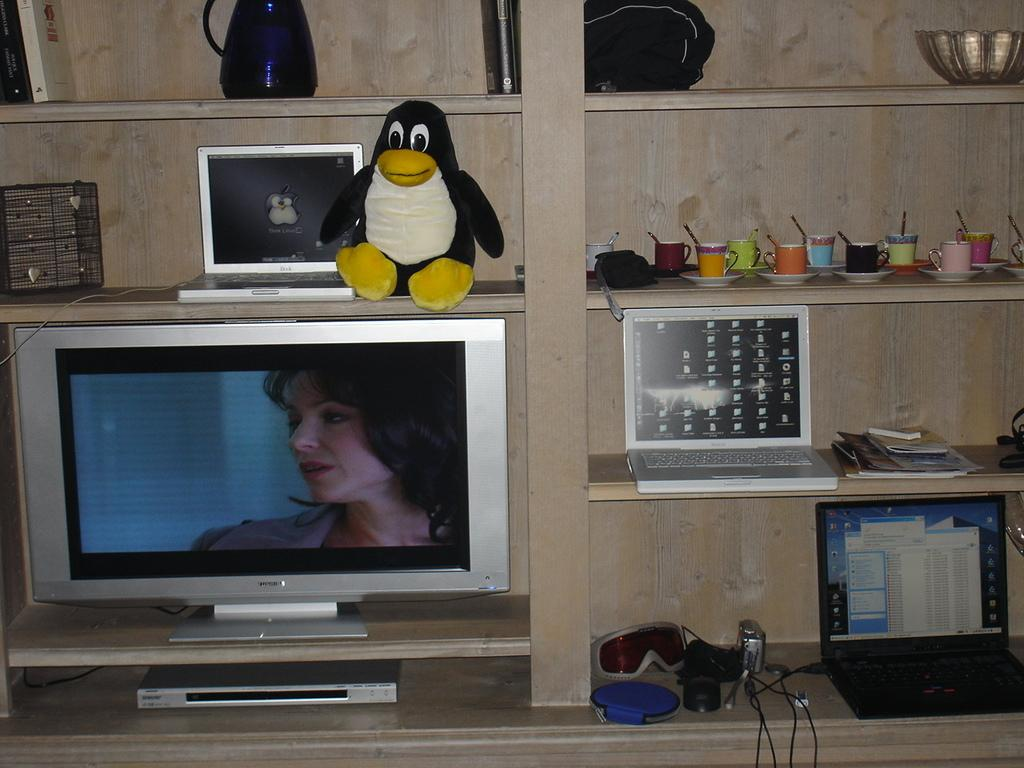What can be seen in the shelves in the image? There are objects placed in shelves in the image. What type of electronic device is present in the image? There is a TV in the image. What other electronic device can be seen in the image? There is a laptop in the image. What type of wood is used to make the invention in the image? There is no invention present in the image, and therefore no specific type of wood can be identified. 